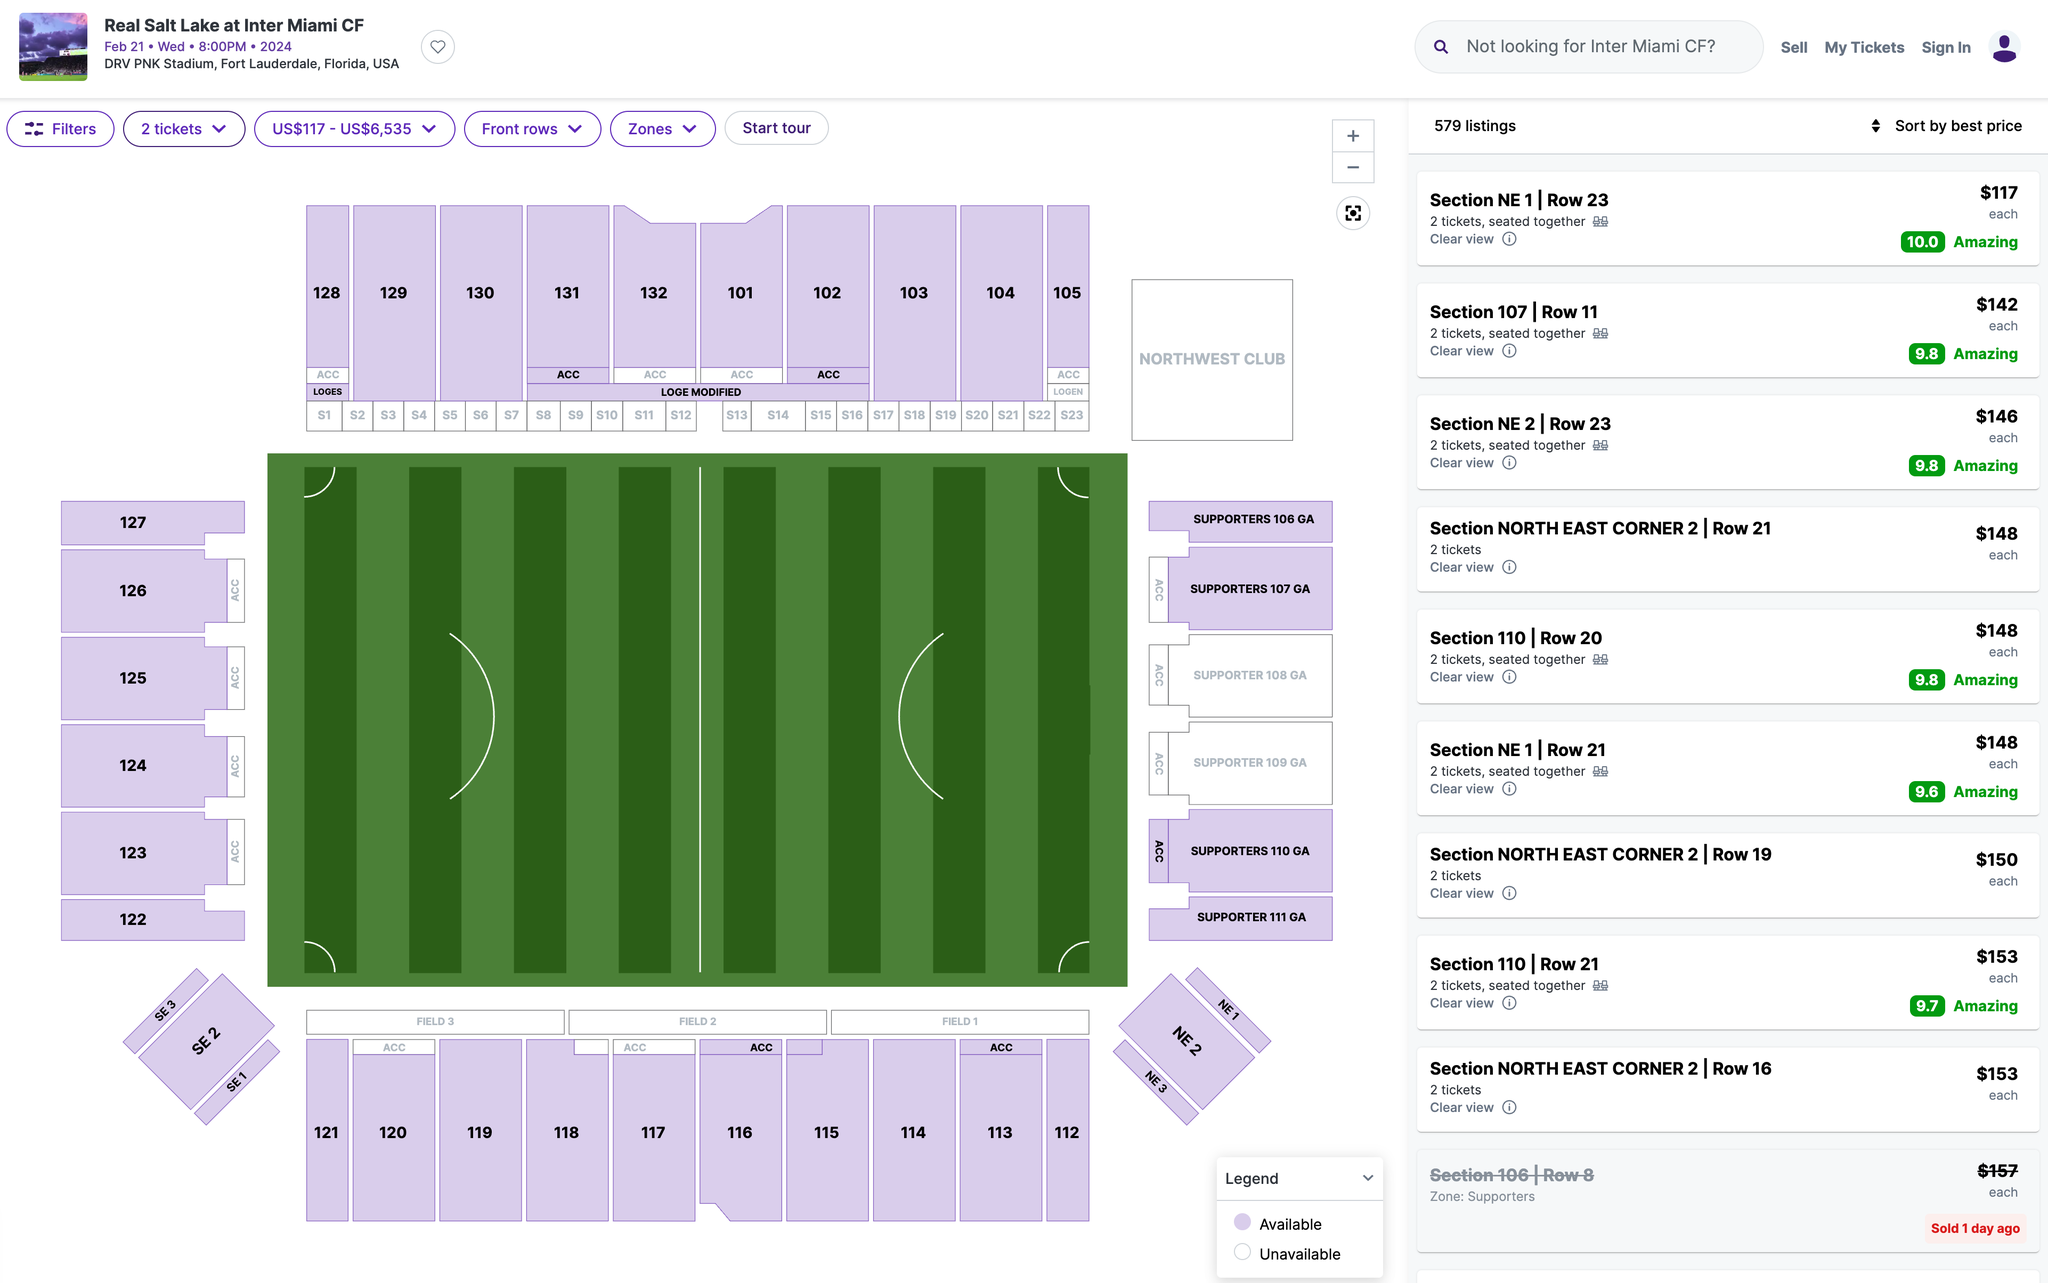Which section's ticket would you recommend I purchase? When selecting a section for a sporting event, there are a few factors to consider: budget, view preference, atmosphere, and amenities. Here are some details about the sections shown in the image:

1. Sections NE 1 and NE 2 (North East Corner) seem to offer a good balance between price and view, with tickets around $117-$150. These corner sections can provide a comprehensive view of the field, allowing you to see plays develop from both sides.

2. Section 107 is more centrally located along the sideline, offering a view directly across the field. It's priced at $142, which is a moderate price point considering the location.

3. The Supporters' Sections (108 GA, 109 GA, 110 GA, 111 GA) are designated for the most passionate fans, often standing, singing, and cheering throughout the game. These sections offer a unique atmosphere but might not be the best for unobstructed views of the game since people may be standing up. Prices here are comparable to other sections, with tickets going for around $148-$153.

If you're looking for the best view within a reasonable price range, Section 107 might be the ideal choice as it offers a central view from the sideline. However, if you're looking to be part of the lively atmosphere with the supporters, the Supporters' Sections would be the place to be.

Ultimately, the best ticket depends on what you value most for your event experience. 